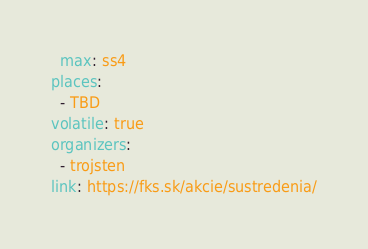<code> <loc_0><loc_0><loc_500><loc_500><_YAML_>  max: ss4
places:
  - TBD
volatile: true
organizers:
  - trojsten
link: https://fks.sk/akcie/sustredenia/</code> 